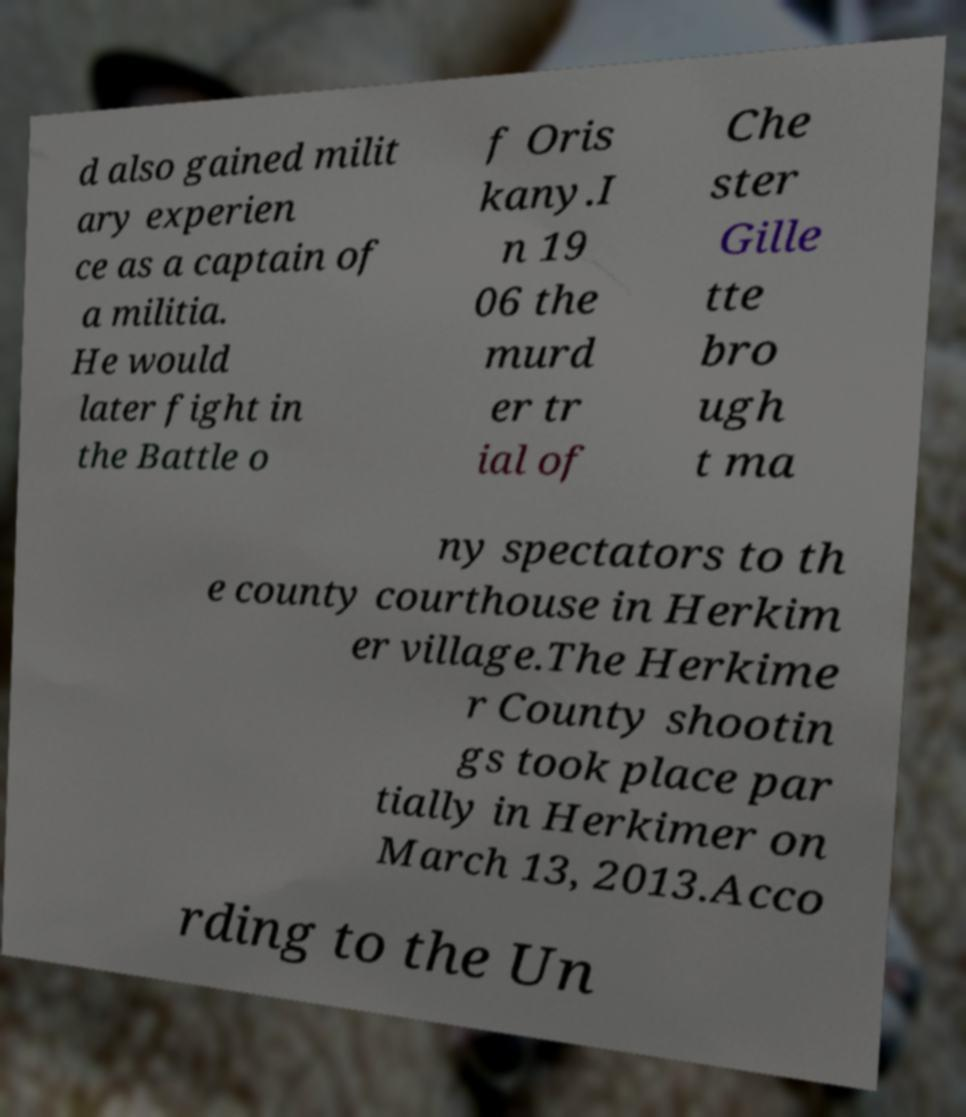Could you extract and type out the text from this image? d also gained milit ary experien ce as a captain of a militia. He would later fight in the Battle o f Oris kany.I n 19 06 the murd er tr ial of Che ster Gille tte bro ugh t ma ny spectators to th e county courthouse in Herkim er village.The Herkime r County shootin gs took place par tially in Herkimer on March 13, 2013.Acco rding to the Un 